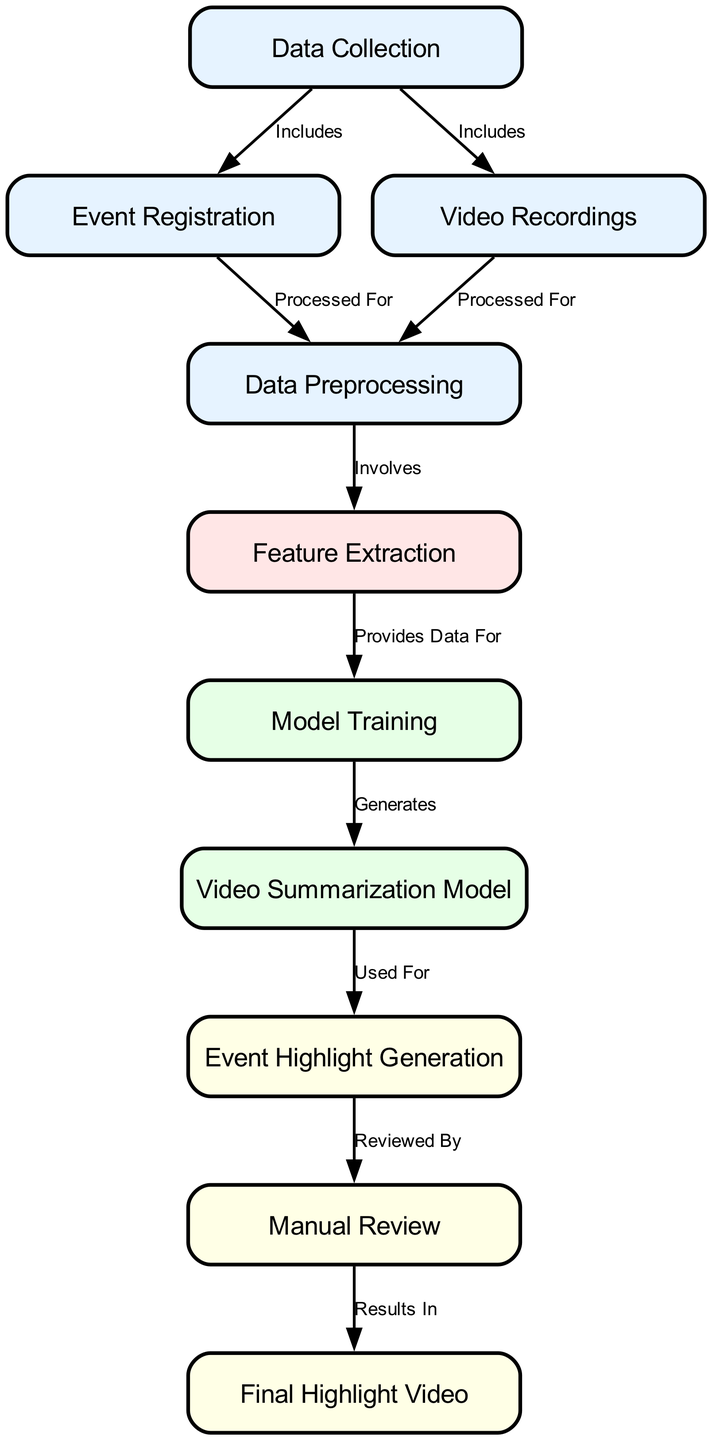What is the first step in the diagram? The first step in the diagram is "Data Collection," as indicated by the lack of any preceding nodes and its position at the top.
Answer: Data Collection How many nodes are in the diagram? By counting all the nodes listed in the data, there are ten distinct nodes present.
Answer: 10 What is the relationship between "Event Registration" and "Data Preprocessing"? The relationship shows that "Event Registration" is processed for "Data Preprocessing," as indicated by the edge connecting these nodes labeled "Processed For."
Answer: Processed For Which node provides data for "Model Training"? The "Feature Extraction" node provides data for "Model Training," as indicated by the edge between these two nodes labeled "Provides Data For."
Answer: Feature Extraction What is the final output of the diagram? The final output of the diagram is represented by the node labeled "Final Highlight Video." It is the last node in the flow.
Answer: Final Highlight Video What comes after "Video Summarization Model" in the flow? The next step after "Video Summarization Model" is "Event Highlight Generation," as shown by the edge labeled "Used For."
Answer: Event Highlight Generation How many edges are depicted in the diagram? By counting the relationships between the nodes, there are nine edges connecting these nodes.
Answer: 9 Which stage involves "Manual Review"? "Manual Review" occurs after "Event Highlight Generation," as indicated by the edge labeled "Reviewed By."
Answer: Event Highlight Generation What does the "Data Preprocessing" phase involve? The "Data Preprocessing" phase involves "Feature Extraction," as shown by the edge labeled "Involves."
Answer: Feature Extraction 